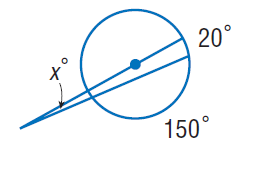Answer the mathemtical geometry problem and directly provide the correct option letter.
Question: Find x. Assume that any segment that appears to be tangent is tangent.
Choices: A: 5 B: 10 C: 20 D: 150 A 